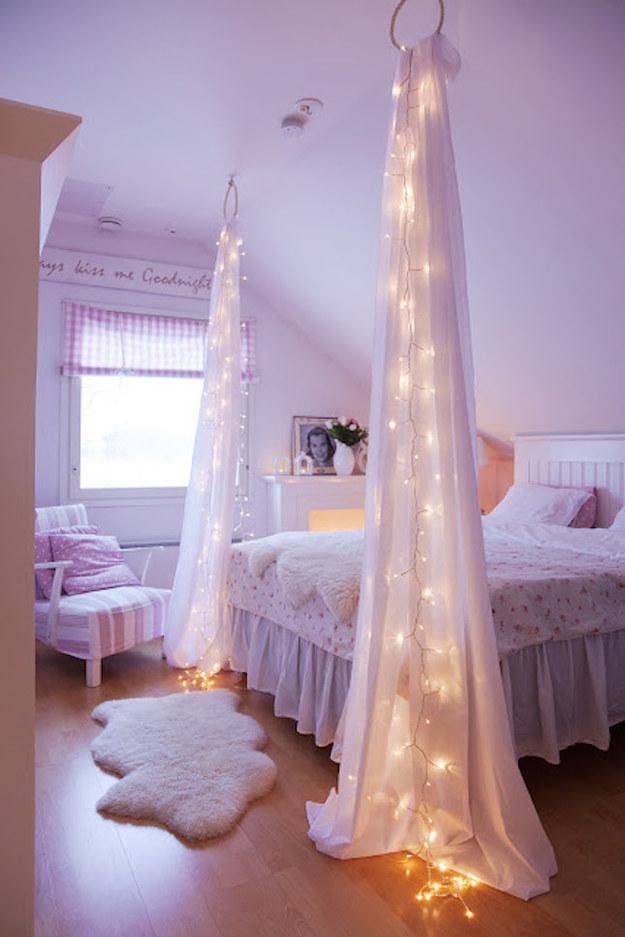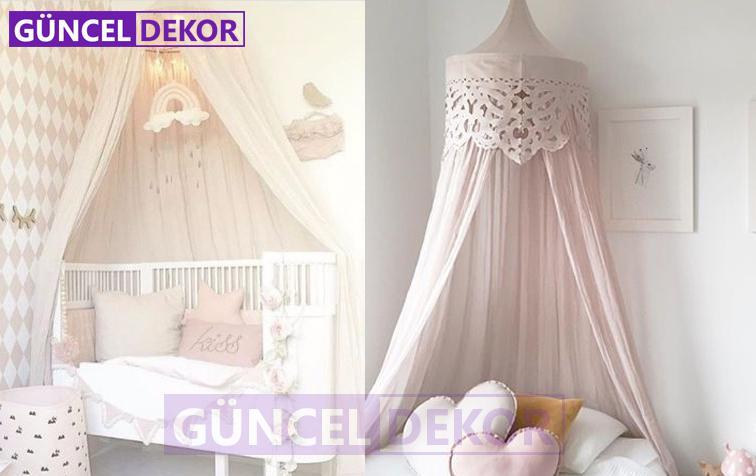The first image is the image on the left, the second image is the image on the right. Given the left and right images, does the statement "All the netting is pink." hold true? Answer yes or no. No. 